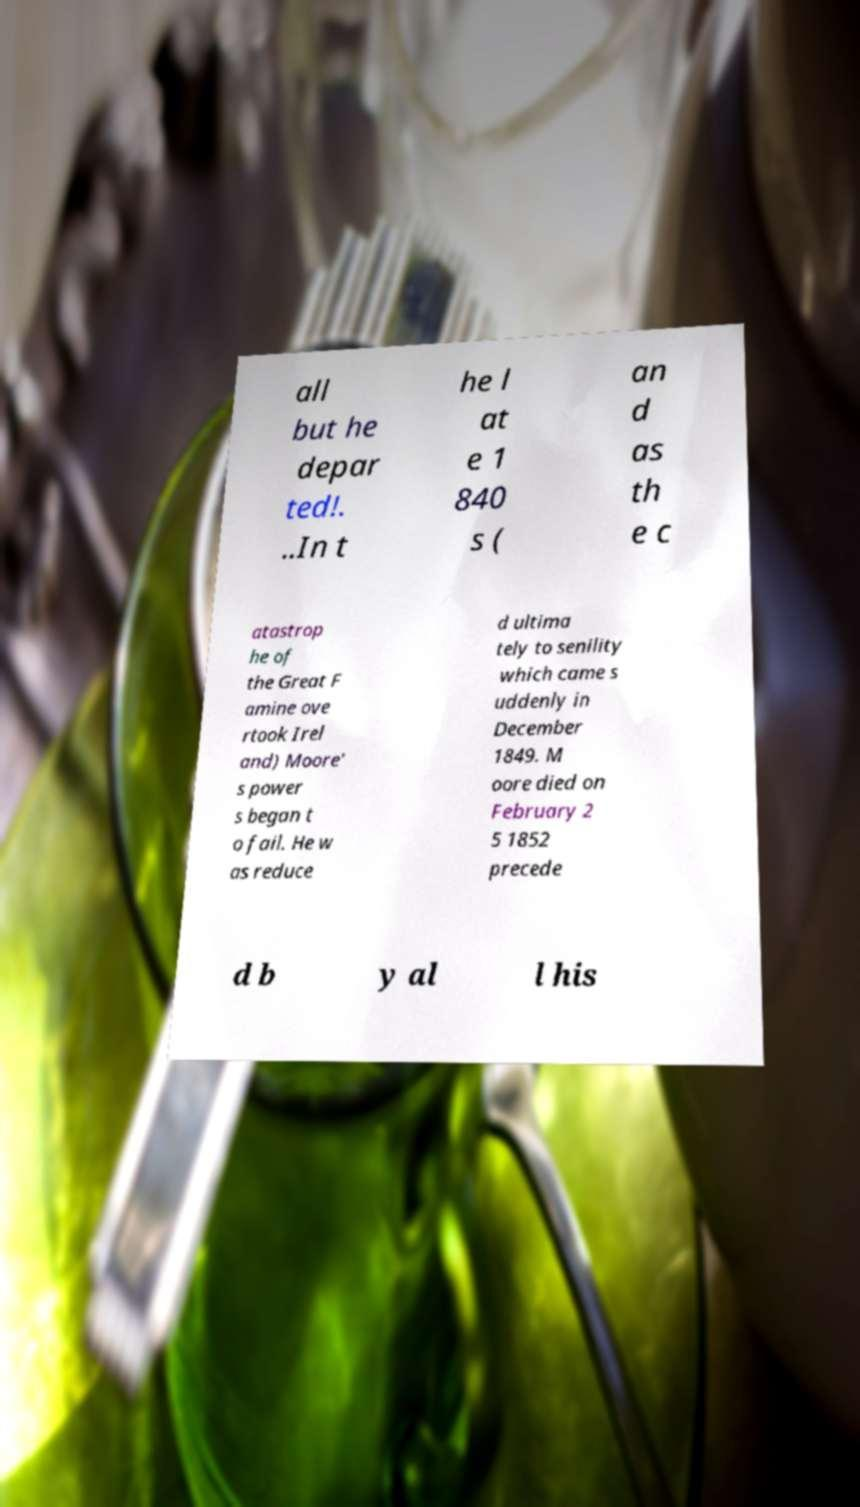Please identify and transcribe the text found in this image. all but he depar ted!. ..In t he l at e 1 840 s ( an d as th e c atastrop he of the Great F amine ove rtook Irel and) Moore' s power s began t o fail. He w as reduce d ultima tely to senility which came s uddenly in December 1849. M oore died on February 2 5 1852 precede d b y al l his 